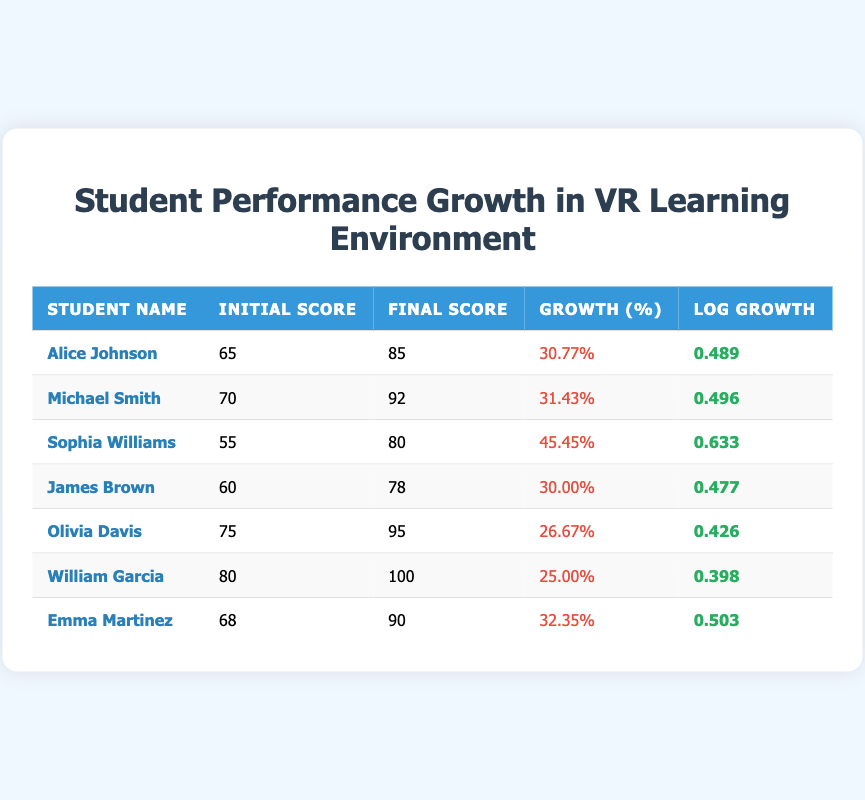What was the initial score of Sophia Williams? Looking at the table, we find the row for Sophia Williams, and her initial score is listed as 55.
Answer: 55 Who had the highest growth percentage? By comparing the growth percentages for all students, we see that Sophia Williams has the highest growth percentage at 45.45%.
Answer: Sophia Williams What is the log growth of Emma Martinez? Referring to Emma Martinez's row, her log growth value is listed as 0.503.
Answer: 0.503 What is the average final score of all students? To find the average final score, we add all the final scores together (85 + 92 + 80 + 78 + 95 + 100 + 90 = 620) and divide by the number of students (7). The average final score is 620/7 = 88.57.
Answer: 88.57 Did any student achieve a growth percentage over 30%? Checking the growth percentages, Alice Johnson, Michael Smith, Sophia Williams, and Emma Martinez all have growth percentages greater than 30%.
Answer: Yes 